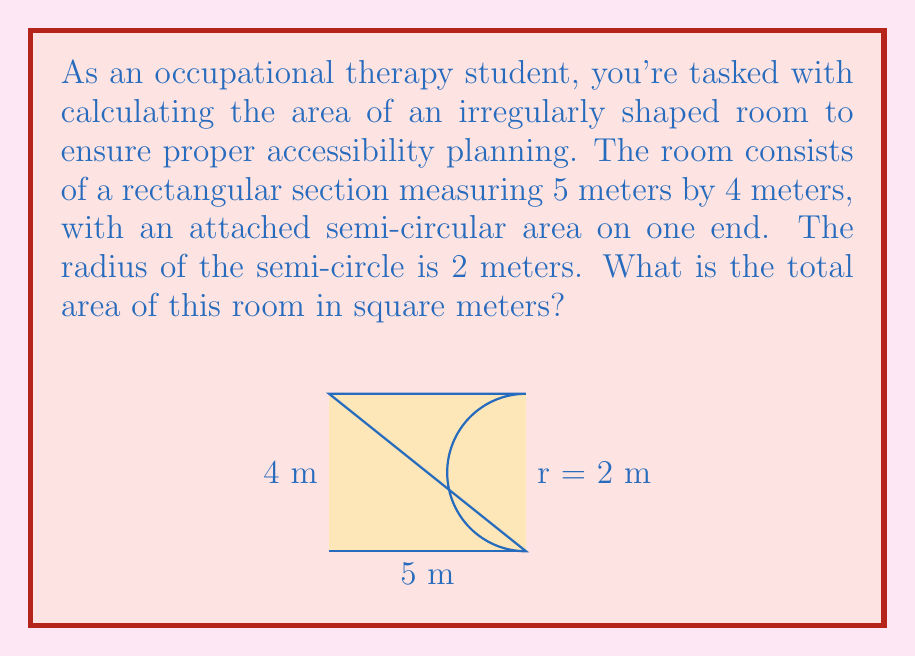Give your solution to this math problem. Let's break this problem down into steps:

1) First, we need to calculate the area of the rectangular section:
   $A_{rectangle} = length \times width$
   $A_{rectangle} = 5 \text{ m} \times 4 \text{ m} = 20 \text{ m}^2$

2) Next, we need to calculate the area of the semi-circular section:
   The area of a full circle is $\pi r^2$, so the area of a semi-circle is half of this.
   $A_{semicircle} = \frac{1}{2} \pi r^2$
   $A_{semicircle} = \frac{1}{2} \pi (2 \text{ m})^2 = 2\pi \text{ m}^2$

3) Now, we add these two areas together:
   $A_{total} = A_{rectangle} + A_{semicircle}$
   $A_{total} = 20 \text{ m}^2 + 2\pi \text{ m}^2$

4) Simplify:
   $A_{total} = (20 + 2\pi) \text{ m}^2$

5) Calculate the final value (rounded to two decimal places):
   $A_{total} \approx 26.28 \text{ m}^2$

This total area is crucial for accessibility planning, as it determines the space available for maneuverability of assistive devices and furniture placement.
Answer: $26.28 \text{ m}^2$ 